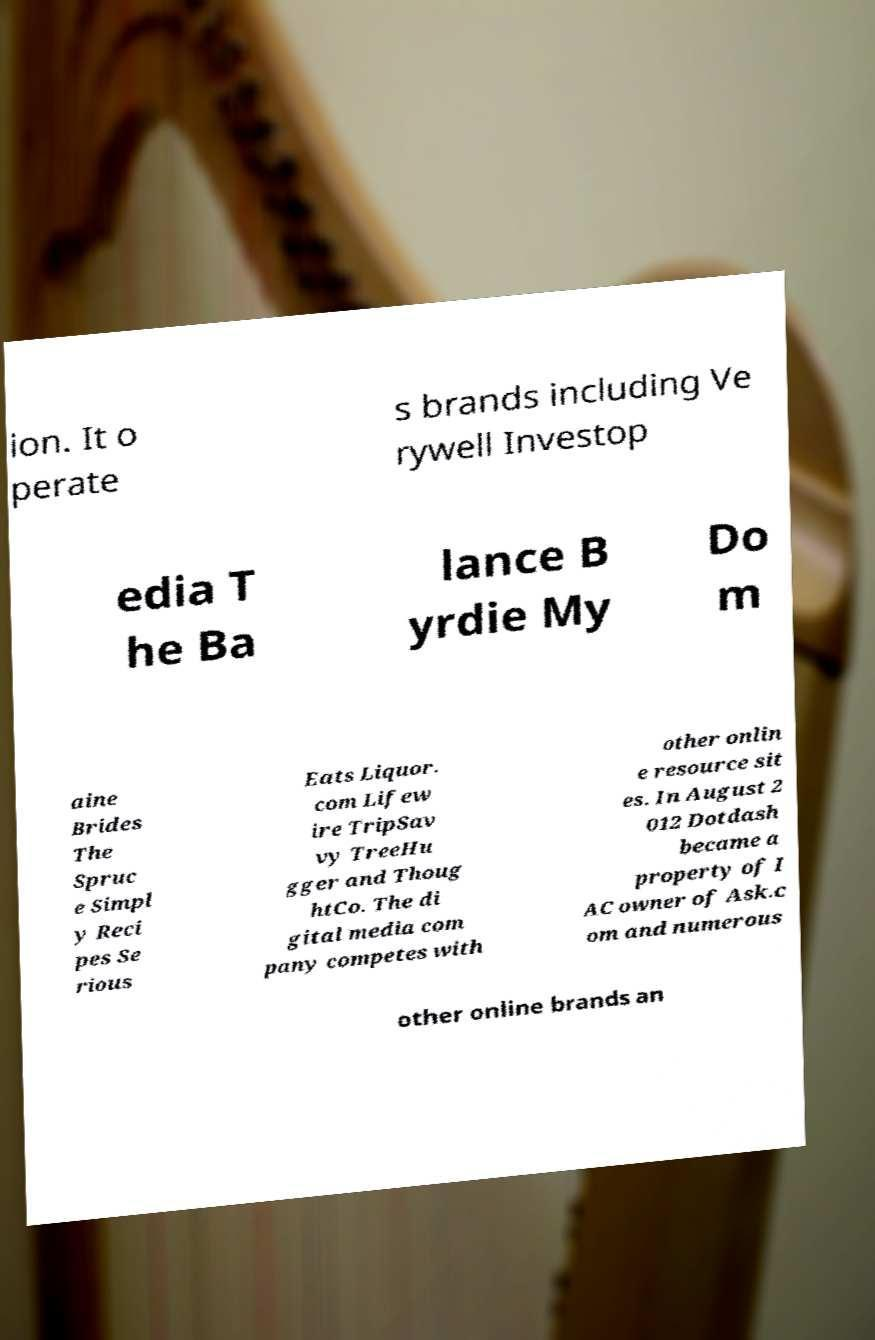For documentation purposes, I need the text within this image transcribed. Could you provide that? ion. It o perate s brands including Ve rywell Investop edia T he Ba lance B yrdie My Do m aine Brides The Spruc e Simpl y Reci pes Se rious Eats Liquor. com Lifew ire TripSav vy TreeHu gger and Thoug htCo. The di gital media com pany competes with other onlin e resource sit es. In August 2 012 Dotdash became a property of I AC owner of Ask.c om and numerous other online brands an 